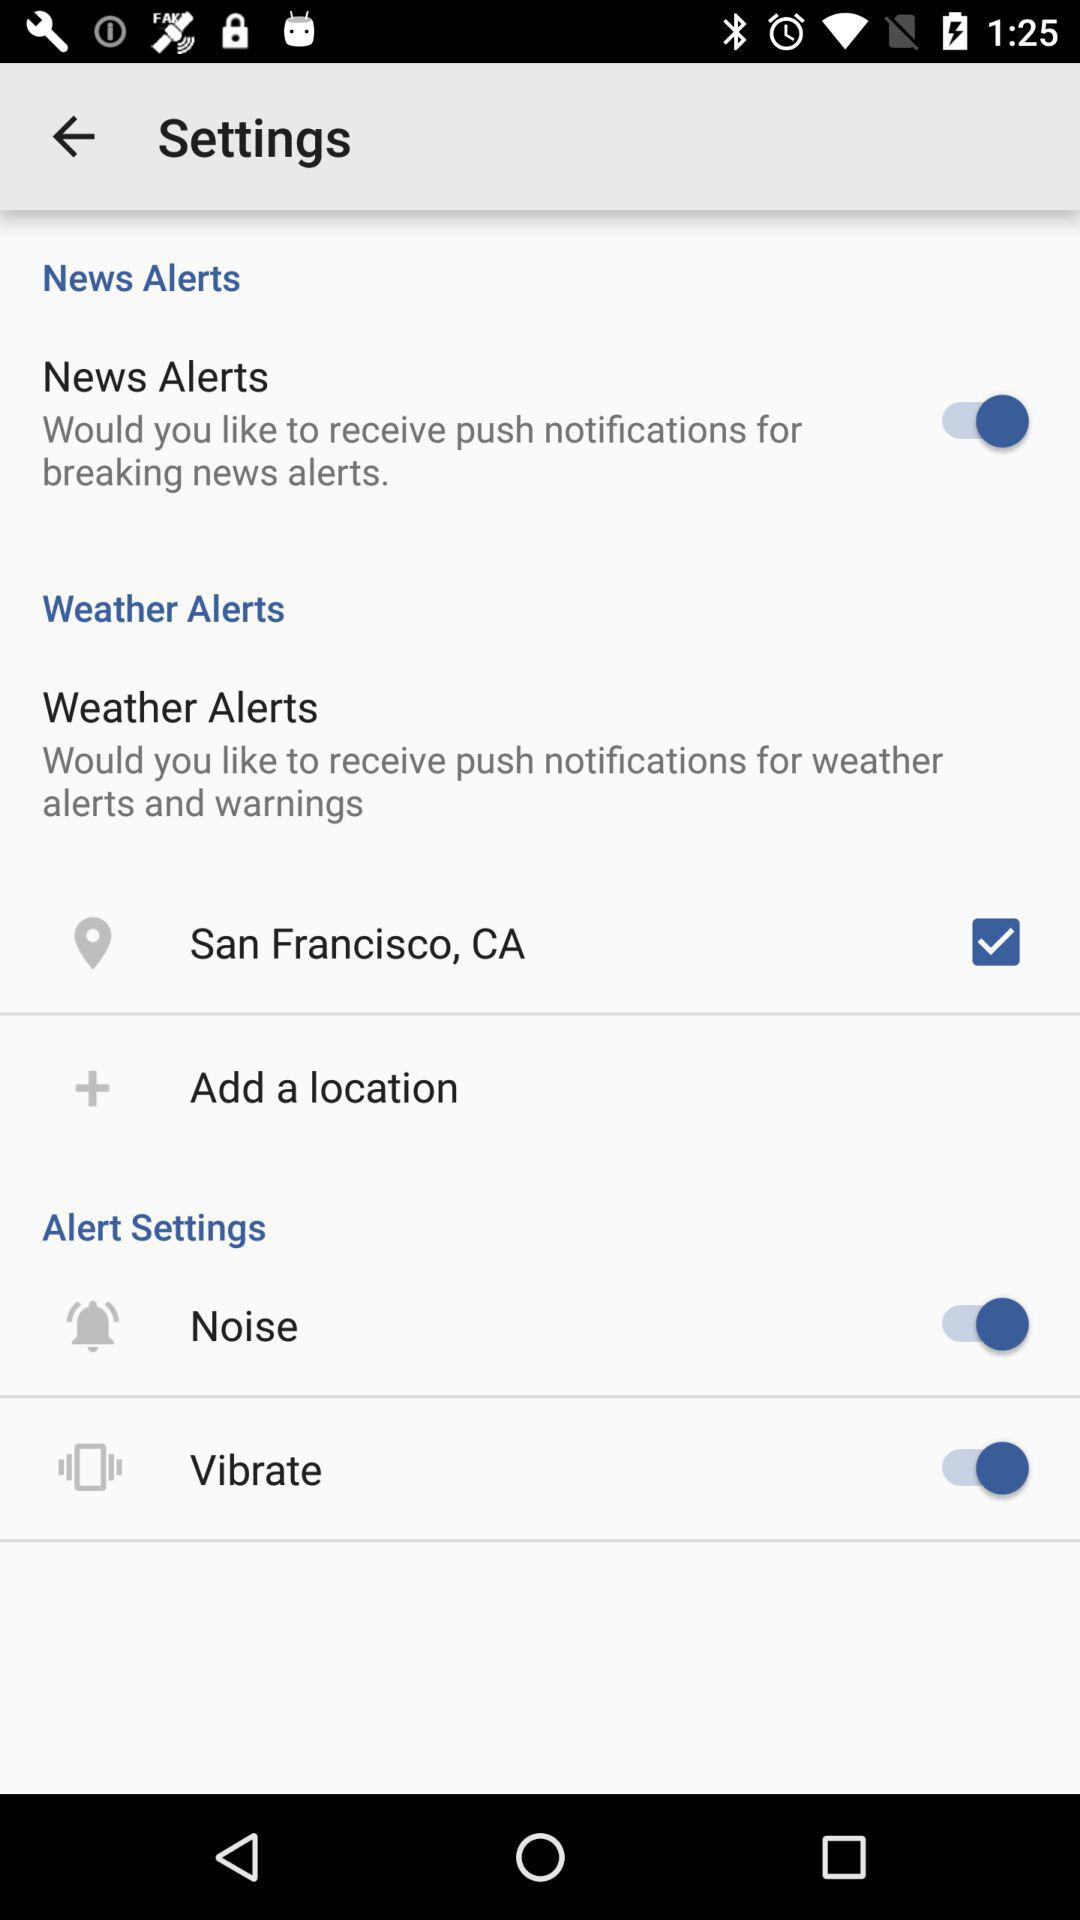What is the checked location? The checked location is San Francisco, CA. 